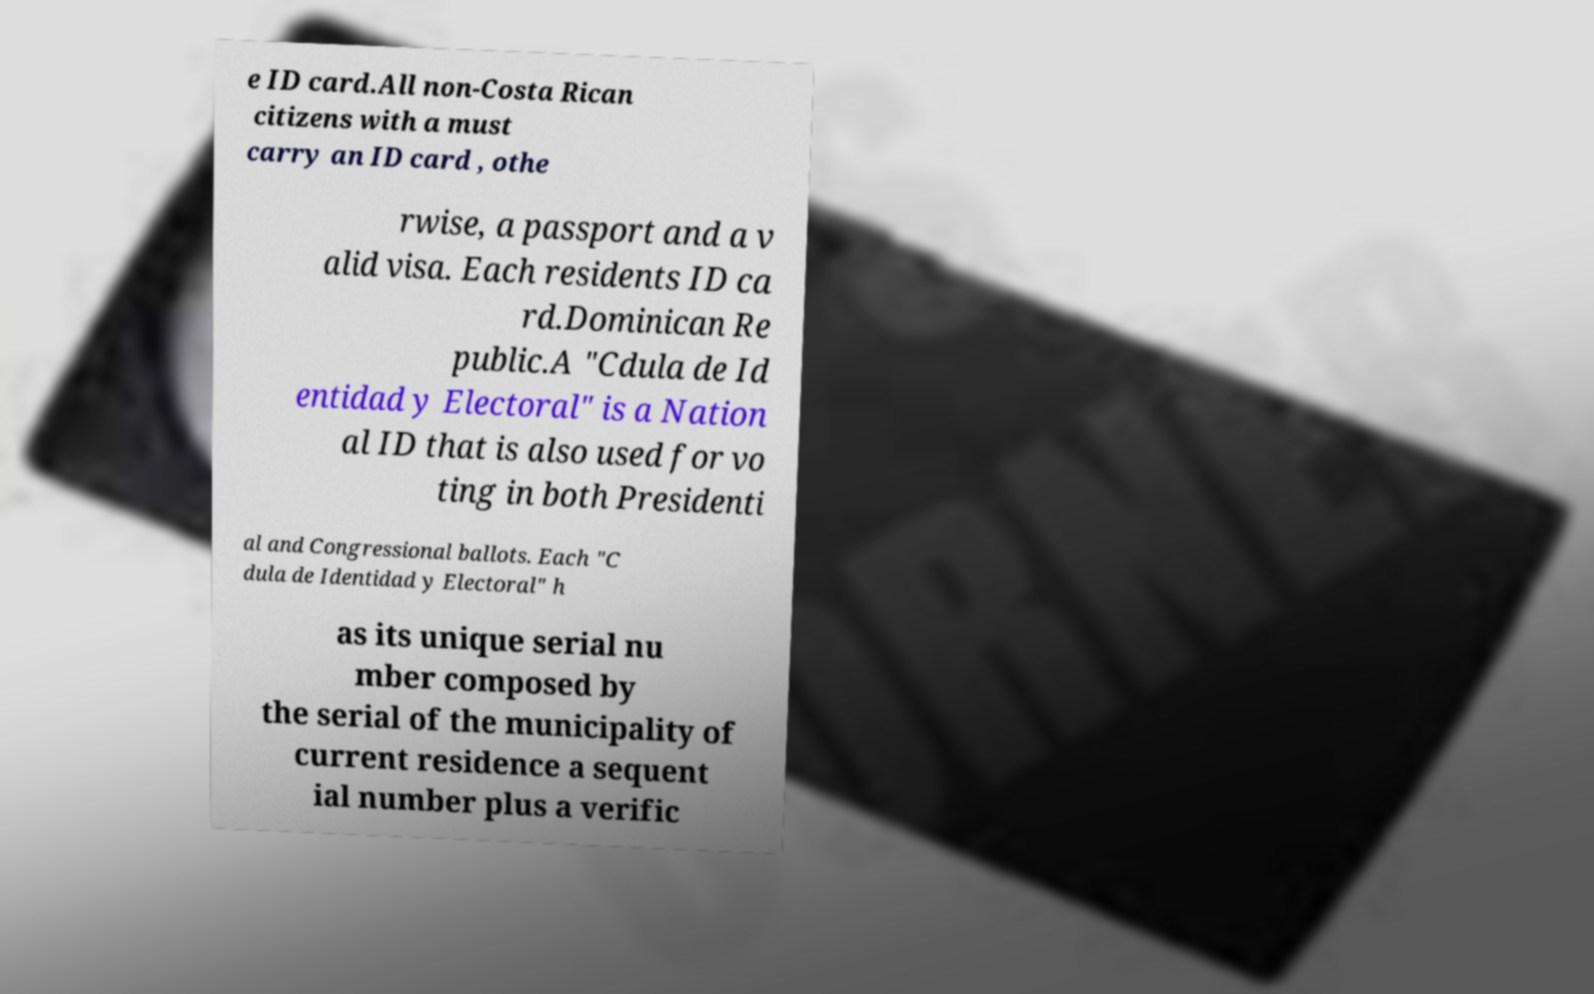Please read and relay the text visible in this image. What does it say? e ID card.All non-Costa Rican citizens with a must carry an ID card , othe rwise, a passport and a v alid visa. Each residents ID ca rd.Dominican Re public.A "Cdula de Id entidad y Electoral" is a Nation al ID that is also used for vo ting in both Presidenti al and Congressional ballots. Each "C dula de Identidad y Electoral" h as its unique serial nu mber composed by the serial of the municipality of current residence a sequent ial number plus a verific 